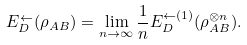Convert formula to latex. <formula><loc_0><loc_0><loc_500><loc_500>E _ { D } ^ { \leftarrow } ( \rho _ { A B } ) = \lim _ { n \rightarrow \infty } \frac { 1 } { n } E _ { D } ^ { \leftarrow ( 1 ) } ( \rho _ { A B } ^ { \otimes n } ) .</formula> 